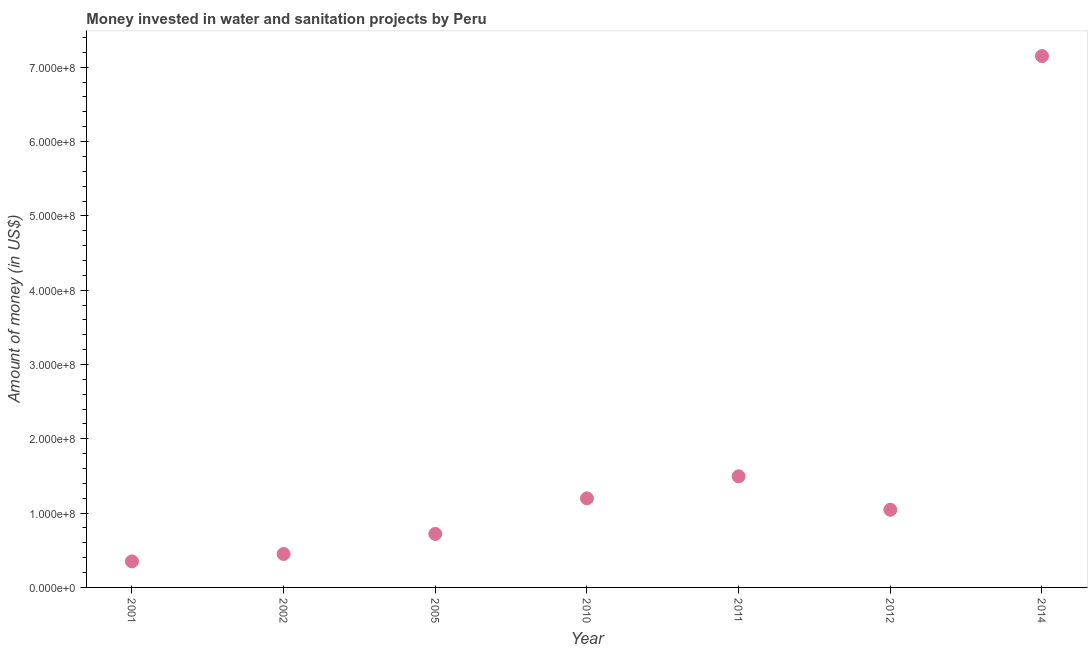What is the investment in 2010?
Keep it short and to the point. 1.20e+08. Across all years, what is the maximum investment?
Ensure brevity in your answer.  7.15e+08. Across all years, what is the minimum investment?
Ensure brevity in your answer.  3.50e+07. What is the sum of the investment?
Keep it short and to the point. 1.24e+09. What is the difference between the investment in 2010 and 2014?
Provide a short and direct response. -5.95e+08. What is the average investment per year?
Your response must be concise. 1.77e+08. What is the median investment?
Your response must be concise. 1.04e+08. What is the ratio of the investment in 2012 to that in 2014?
Keep it short and to the point. 0.15. Is the investment in 2005 less than that in 2010?
Ensure brevity in your answer.  Yes. What is the difference between the highest and the second highest investment?
Offer a terse response. 5.66e+08. What is the difference between the highest and the lowest investment?
Provide a short and direct response. 6.80e+08. Does the investment monotonically increase over the years?
Offer a very short reply. No. How many years are there in the graph?
Offer a very short reply. 7. Are the values on the major ticks of Y-axis written in scientific E-notation?
Provide a succinct answer. Yes. Does the graph contain grids?
Provide a short and direct response. No. What is the title of the graph?
Ensure brevity in your answer.  Money invested in water and sanitation projects by Peru. What is the label or title of the X-axis?
Your answer should be very brief. Year. What is the label or title of the Y-axis?
Keep it short and to the point. Amount of money (in US$). What is the Amount of money (in US$) in 2001?
Ensure brevity in your answer.  3.50e+07. What is the Amount of money (in US$) in 2002?
Your answer should be very brief. 4.50e+07. What is the Amount of money (in US$) in 2005?
Give a very brief answer. 7.20e+07. What is the Amount of money (in US$) in 2010?
Keep it short and to the point. 1.20e+08. What is the Amount of money (in US$) in 2011?
Provide a succinct answer. 1.50e+08. What is the Amount of money (in US$) in 2012?
Ensure brevity in your answer.  1.04e+08. What is the Amount of money (in US$) in 2014?
Provide a succinct answer. 7.15e+08. What is the difference between the Amount of money (in US$) in 2001 and 2002?
Provide a succinct answer. -1.00e+07. What is the difference between the Amount of money (in US$) in 2001 and 2005?
Provide a short and direct response. -3.70e+07. What is the difference between the Amount of money (in US$) in 2001 and 2010?
Your answer should be compact. -8.48e+07. What is the difference between the Amount of money (in US$) in 2001 and 2011?
Keep it short and to the point. -1.14e+08. What is the difference between the Amount of money (in US$) in 2001 and 2012?
Make the answer very short. -6.95e+07. What is the difference between the Amount of money (in US$) in 2001 and 2014?
Make the answer very short. -6.80e+08. What is the difference between the Amount of money (in US$) in 2002 and 2005?
Offer a terse response. -2.70e+07. What is the difference between the Amount of money (in US$) in 2002 and 2010?
Ensure brevity in your answer.  -7.48e+07. What is the difference between the Amount of money (in US$) in 2002 and 2011?
Provide a succinct answer. -1.04e+08. What is the difference between the Amount of money (in US$) in 2002 and 2012?
Ensure brevity in your answer.  -5.95e+07. What is the difference between the Amount of money (in US$) in 2002 and 2014?
Offer a terse response. -6.70e+08. What is the difference between the Amount of money (in US$) in 2005 and 2010?
Offer a terse response. -4.78e+07. What is the difference between the Amount of money (in US$) in 2005 and 2011?
Ensure brevity in your answer.  -7.75e+07. What is the difference between the Amount of money (in US$) in 2005 and 2012?
Provide a short and direct response. -3.25e+07. What is the difference between the Amount of money (in US$) in 2005 and 2014?
Provide a succinct answer. -6.43e+08. What is the difference between the Amount of money (in US$) in 2010 and 2011?
Provide a succinct answer. -2.97e+07. What is the difference between the Amount of money (in US$) in 2010 and 2012?
Your answer should be compact. 1.53e+07. What is the difference between the Amount of money (in US$) in 2010 and 2014?
Make the answer very short. -5.95e+08. What is the difference between the Amount of money (in US$) in 2011 and 2012?
Offer a very short reply. 4.50e+07. What is the difference between the Amount of money (in US$) in 2011 and 2014?
Offer a terse response. -5.66e+08. What is the difference between the Amount of money (in US$) in 2012 and 2014?
Provide a short and direct response. -6.10e+08. What is the ratio of the Amount of money (in US$) in 2001 to that in 2002?
Give a very brief answer. 0.78. What is the ratio of the Amount of money (in US$) in 2001 to that in 2005?
Your answer should be compact. 0.49. What is the ratio of the Amount of money (in US$) in 2001 to that in 2010?
Give a very brief answer. 0.29. What is the ratio of the Amount of money (in US$) in 2001 to that in 2011?
Ensure brevity in your answer.  0.23. What is the ratio of the Amount of money (in US$) in 2001 to that in 2012?
Provide a short and direct response. 0.34. What is the ratio of the Amount of money (in US$) in 2001 to that in 2014?
Your answer should be very brief. 0.05. What is the ratio of the Amount of money (in US$) in 2002 to that in 2005?
Offer a terse response. 0.62. What is the ratio of the Amount of money (in US$) in 2002 to that in 2010?
Your answer should be compact. 0.38. What is the ratio of the Amount of money (in US$) in 2002 to that in 2011?
Ensure brevity in your answer.  0.3. What is the ratio of the Amount of money (in US$) in 2002 to that in 2012?
Keep it short and to the point. 0.43. What is the ratio of the Amount of money (in US$) in 2002 to that in 2014?
Provide a succinct answer. 0.06. What is the ratio of the Amount of money (in US$) in 2005 to that in 2010?
Your answer should be compact. 0.6. What is the ratio of the Amount of money (in US$) in 2005 to that in 2011?
Keep it short and to the point. 0.48. What is the ratio of the Amount of money (in US$) in 2005 to that in 2012?
Make the answer very short. 0.69. What is the ratio of the Amount of money (in US$) in 2005 to that in 2014?
Offer a terse response. 0.1. What is the ratio of the Amount of money (in US$) in 2010 to that in 2011?
Your answer should be very brief. 0.8. What is the ratio of the Amount of money (in US$) in 2010 to that in 2012?
Offer a terse response. 1.15. What is the ratio of the Amount of money (in US$) in 2010 to that in 2014?
Your answer should be very brief. 0.17. What is the ratio of the Amount of money (in US$) in 2011 to that in 2012?
Provide a succinct answer. 1.43. What is the ratio of the Amount of money (in US$) in 2011 to that in 2014?
Your answer should be compact. 0.21. What is the ratio of the Amount of money (in US$) in 2012 to that in 2014?
Keep it short and to the point. 0.15. 